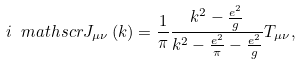<formula> <loc_0><loc_0><loc_500><loc_500>i \ m a t h s c r { J } _ { \mu \nu } \left ( k \right ) = \frac { 1 } { \pi } \frac { k ^ { 2 } - \frac { e ^ { 2 } } { g } } { k ^ { 2 } - \frac { e ^ { 2 } } { \pi } - \frac { e ^ { 2 } } { g } } T _ { \mu \nu } ,</formula> 